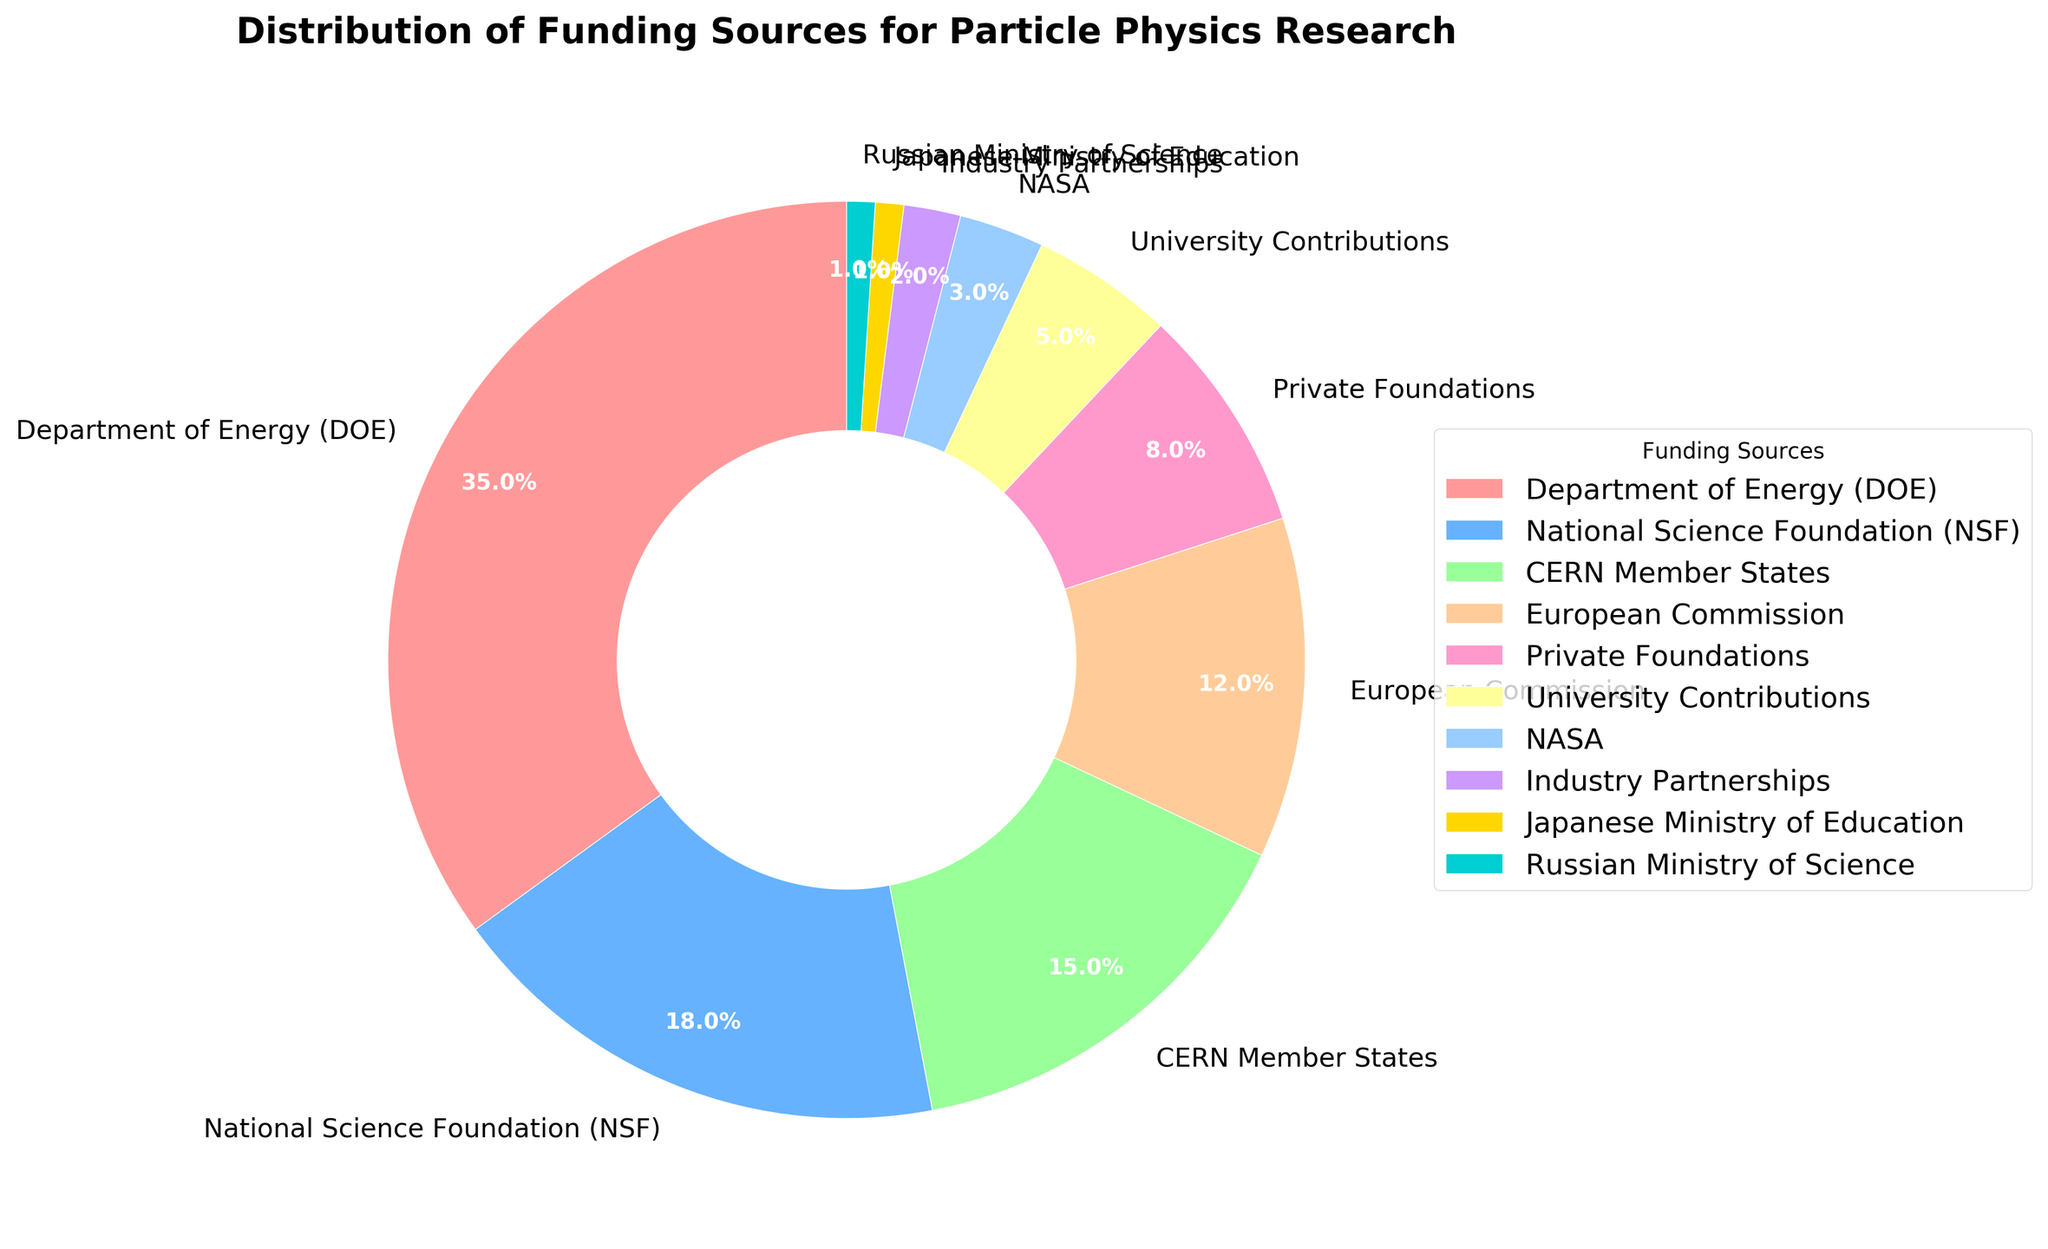What is the largest funding source for particle physics research? The Department of Energy (DOE) has the highest percentage in the pie chart, at 35%.
Answer: Department of Energy (DOE) How much more funding does the National Science Foundation (NSF) receive compared to NASA? The NSF receives 18% of the funding while NASA receives 3%. Using subtraction: 18% - 3% = 15%.
Answer: 15% Which two funding sources contribute the least and what are their combined percentages? The two funding sources with the smallest percentages are the Japanese Ministry of Education and the Russian Ministry of Science, each contributing 1%. Combined, their contribution is 1% + 1% = 2%.
Answer: 2% What is the total percentage of funding provided by government sources (DOE, NSF, NASA, Japanese Ministry of Education, and Russian Ministry of Science)? Summing the percentages of DOE (35%), NSF (18%), NASA (3%), Japanese Ministry of Education (1%), and Russian Ministry of Science (1%): 35% + 18% + 3% + 1% + 1% = 58%.
Answer: 58% Between the European Commission and Private Foundations, which provides more funding and by how much? The European Commission provides 12% of the funding while Private Foundations provide 8%. The difference is 12% - 8% = 4%.
Answer: European Commission by 4% What fraction of the funding does University Contributions and Industry Partnerships combined represent? University Contributions provide 5% and Industry Partnerships provide 2%. Combined, they represent 5% + 2% = 7%. This is 7 out of 100 total, which simplifies to 7/100 or 0.07.
Answer: 7% Which funding source is represented by a bright yellow color? The funding source represented by the bright yellow color is the Japanese Ministry of Education.
Answer: Japanese Ministry of Education If the funding from CERN Member States is combined with the funding from the European Commission, what is the total funding percentage from these two European sources? The funding percentage from CERN Member States is 15% and from the European Commission is 12%. Combined, they represent 15% + 12% = 27%.
Answer: 27% How does the contribution of Private Foundations compare with that of NASA? Private Foundations contribute 8% of the funding while NASA contributes 3%. Private Foundations contribute 5% more than NASA, as 8% - 3% = 5%.
Answer: 5% If industry partnerships increased their funding to match the funding percentage of university contributions, what would be the new total percentage for industry partnerships? Currently, Industry Partnerships contribute 2%. If they increased their contribution to match University Contributions at 5%, the new total for Industry Partnerships would be 5%.
Answer: 5% 